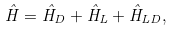<formula> <loc_0><loc_0><loc_500><loc_500>\hat { H } = \hat { H } _ { D } + \hat { H } _ { L } + \hat { H } _ { L D } ,</formula> 